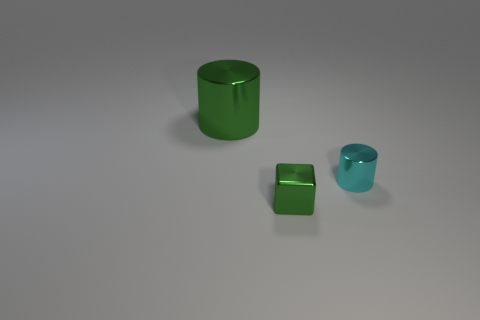Are there shadows being cast by the objects and what does that tell us about the light source? Indeed, each object casts a soft-edged shadow that fades gently into the surface, suggesting the presence of a diffused light source that's positioned above and to the side, subtly articulating the shapes and spatial relationships between them. 